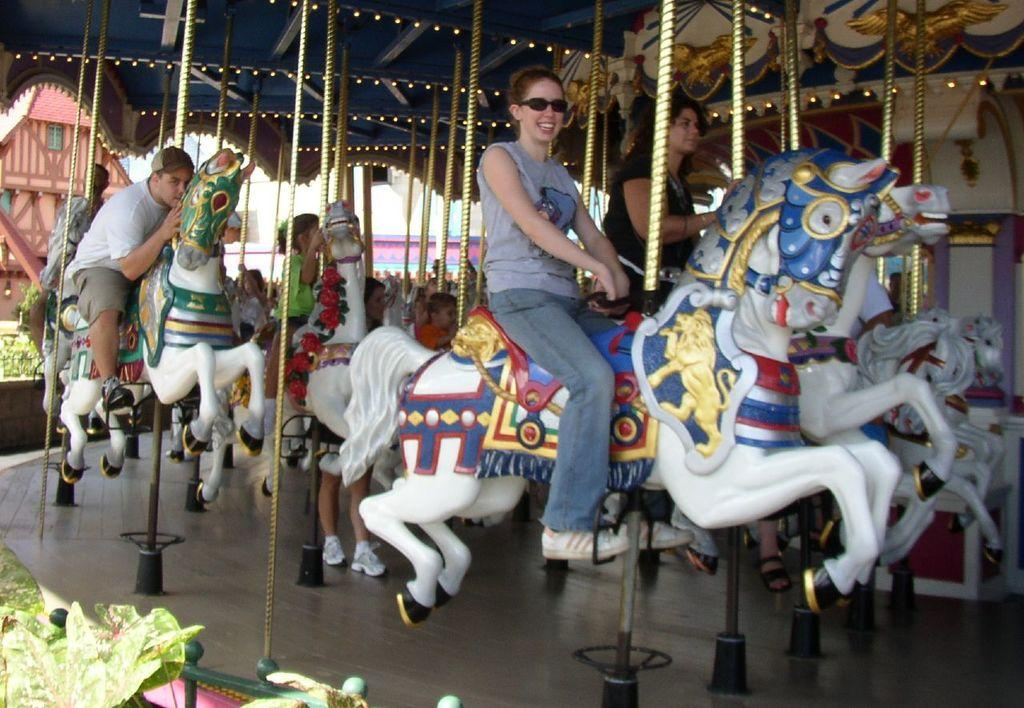Who is present in the image? There are persons and children in the image. What are the persons and children doing in the image? They are playing on a fun ride. What can be seen in the background of the image? There are plants and buildings in the background of the image. Where is the beggar sitting in the image? There is no beggar present in the image. What type of rose can be seen in the image? There are no roses present in the image. 